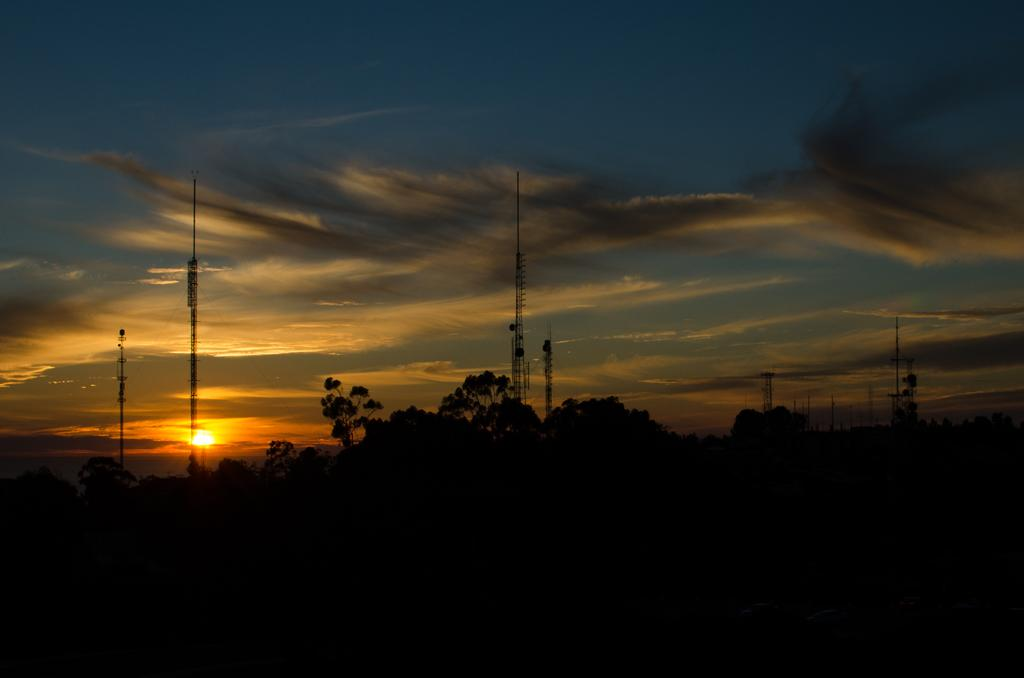What is there are two main subjects in the center of the image. What are they? There are trees and poles in the center of the image. What can be seen at the top of the image? The sky is visible at the top side of the image. What might be suggested by the appearance of the sky in the image? The image appears to depict a sunset. How many sheep can be seen grazing in the image? There are no sheep present in the image. What time does the crib indicate in the image? There is no crib present in the image. 